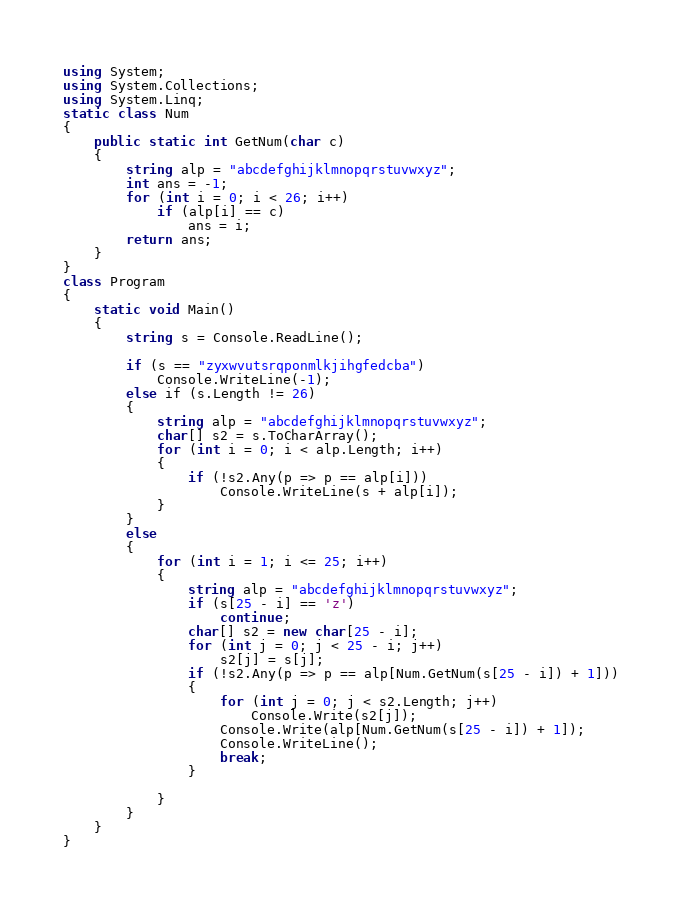Convert code to text. <code><loc_0><loc_0><loc_500><loc_500><_C#_>using System;
using System.Collections;
using System.Linq;
static class Num
{
    public static int GetNum(char c)
    {
        string alp = "abcdefghijklmnopqrstuvwxyz";
        int ans = -1;
        for (int i = 0; i < 26; i++)
            if (alp[i] == c)
                ans = i;
        return ans;
    }
}
class Program
{
    static void Main()
    {
        string s = Console.ReadLine();

        if (s == "zyxwvutsrqponmlkjihgfedcba")
            Console.WriteLine(-1);
        else if (s.Length != 26)
        {
            string alp = "abcdefghijklmnopqrstuvwxyz";
            char[] s2 = s.ToCharArray();
            for (int i = 0; i < alp.Length; i++)
            {
                if (!s2.Any(p => p == alp[i]))
                    Console.WriteLine(s + alp[i]);
            }
        }
        else
        {
            for (int i = 1; i <= 25; i++)
            {
                string alp = "abcdefghijklmnopqrstuvwxyz";
                if (s[25 - i] == 'z')
                    continue;
                char[] s2 = new char[25 - i];
                for (int j = 0; j < 25 - i; j++)
                    s2[j] = s[j];
                if (!s2.Any(p => p == alp[Num.GetNum(s[25 - i]) + 1]))
                {
                    for (int j = 0; j < s2.Length; j++)
                        Console.Write(s2[j]);
                    Console.Write(alp[Num.GetNum(s[25 - i]) + 1]);
                    Console.WriteLine();
                    break;
                }

            }
        }
    }
}</code> 